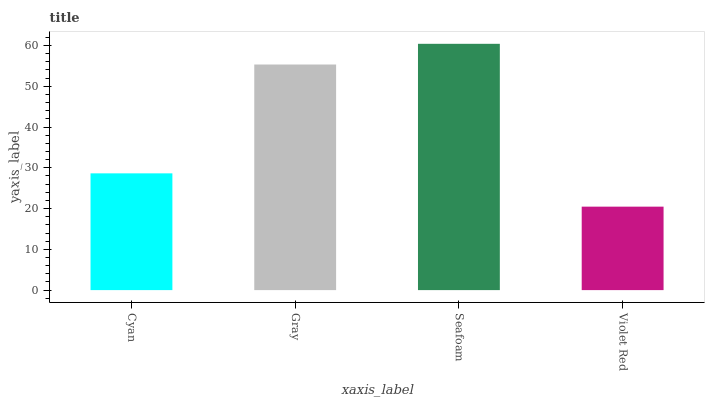Is Violet Red the minimum?
Answer yes or no. Yes. Is Seafoam the maximum?
Answer yes or no. Yes. Is Gray the minimum?
Answer yes or no. No. Is Gray the maximum?
Answer yes or no. No. Is Gray greater than Cyan?
Answer yes or no. Yes. Is Cyan less than Gray?
Answer yes or no. Yes. Is Cyan greater than Gray?
Answer yes or no. No. Is Gray less than Cyan?
Answer yes or no. No. Is Gray the high median?
Answer yes or no. Yes. Is Cyan the low median?
Answer yes or no. Yes. Is Seafoam the high median?
Answer yes or no. No. Is Seafoam the low median?
Answer yes or no. No. 